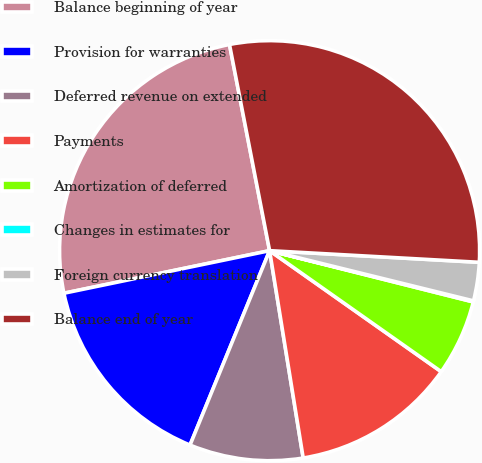Convert chart to OTSL. <chart><loc_0><loc_0><loc_500><loc_500><pie_chart><fcel>Balance beginning of year<fcel>Provision for warranties<fcel>Deferred revenue on extended<fcel>Payments<fcel>Amortization of deferred<fcel>Changes in estimates for<fcel>Foreign currency translation<fcel>Balance end of year<nl><fcel>25.19%<fcel>15.57%<fcel>8.74%<fcel>12.67%<fcel>5.85%<fcel>0.08%<fcel>2.96%<fcel>28.94%<nl></chart> 